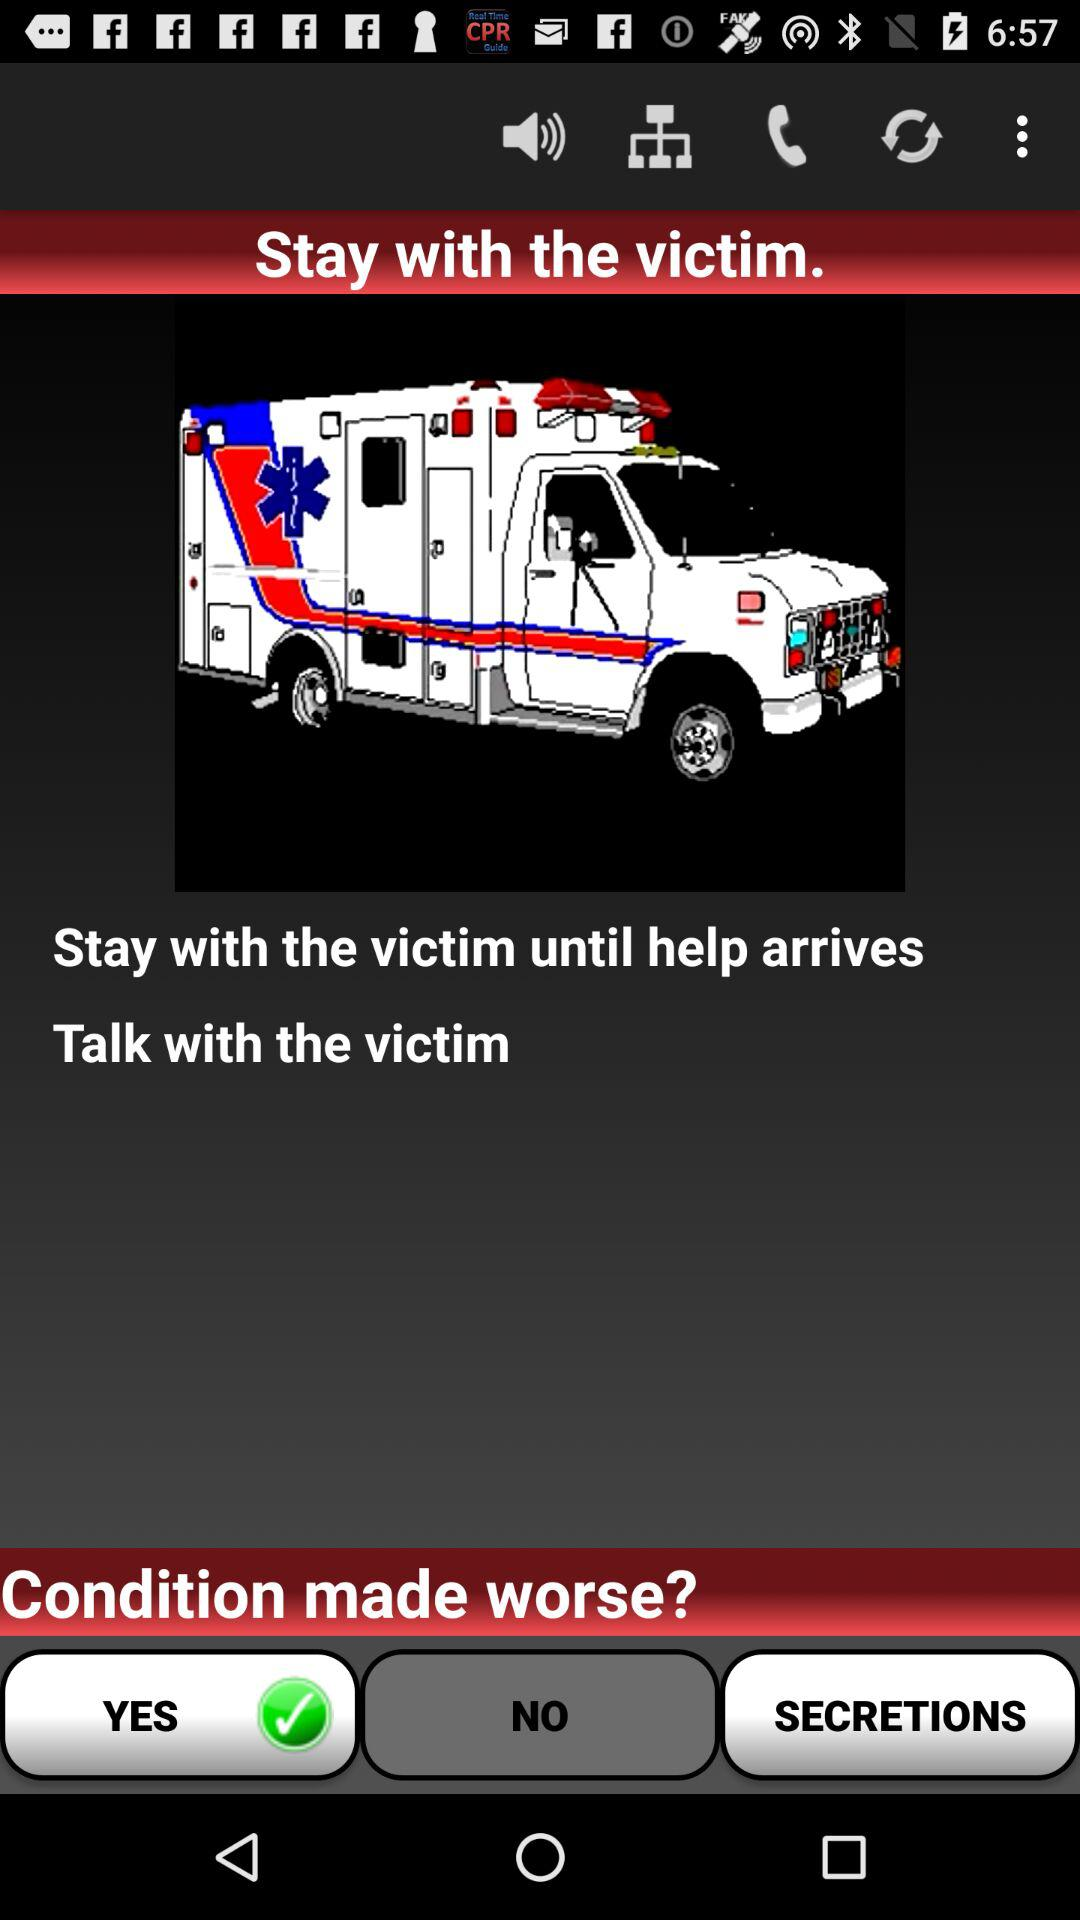Which option is selected for "Condition made worse"? The selected option is "YES". 